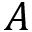Convert formula to latex. <formula><loc_0><loc_0><loc_500><loc_500>A</formula> 